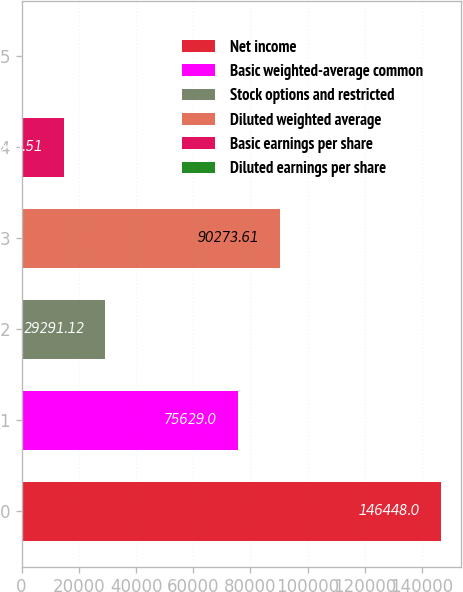<chart> <loc_0><loc_0><loc_500><loc_500><bar_chart><fcel>Net income<fcel>Basic weighted-average common<fcel>Stock options and restricted<fcel>Diluted weighted average<fcel>Basic earnings per share<fcel>Diluted earnings per share<nl><fcel>146448<fcel>75629<fcel>29291.1<fcel>90273.6<fcel>14646.5<fcel>1.9<nl></chart> 